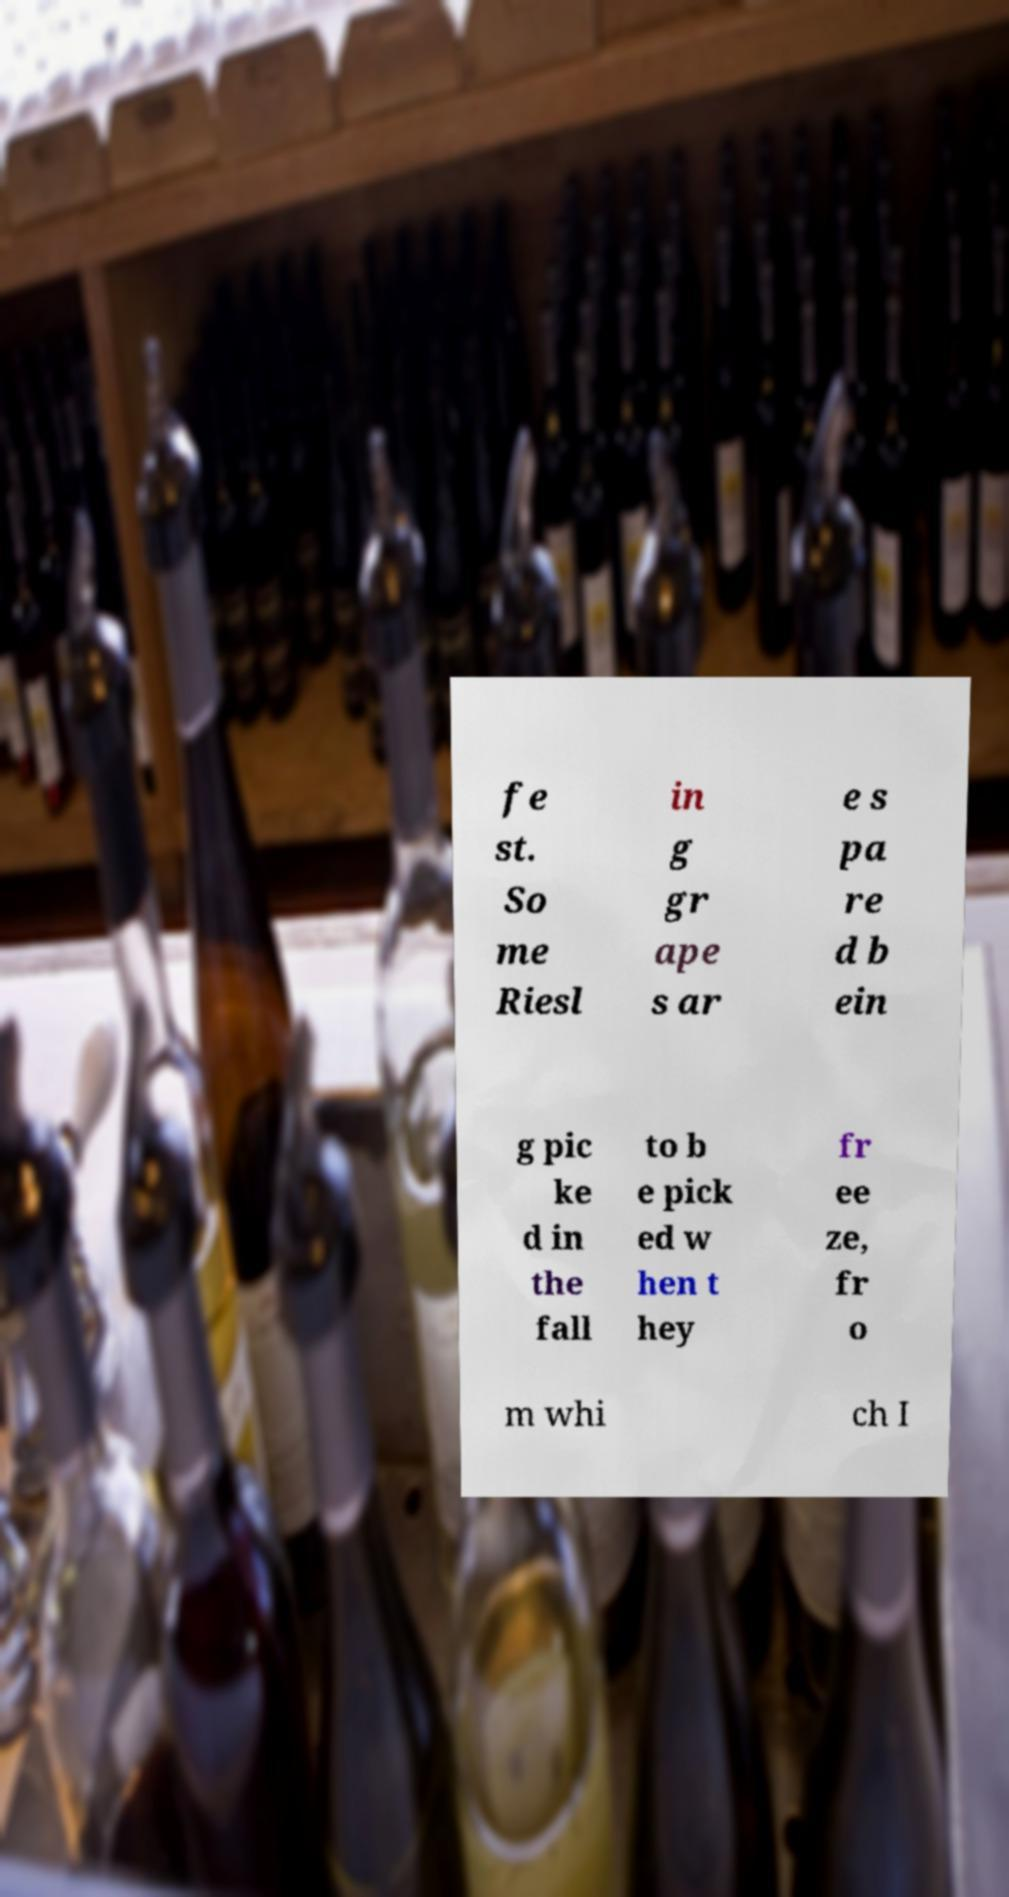I need the written content from this picture converted into text. Can you do that? fe st. So me Riesl in g gr ape s ar e s pa re d b ein g pic ke d in the fall to b e pick ed w hen t hey fr ee ze, fr o m whi ch I 